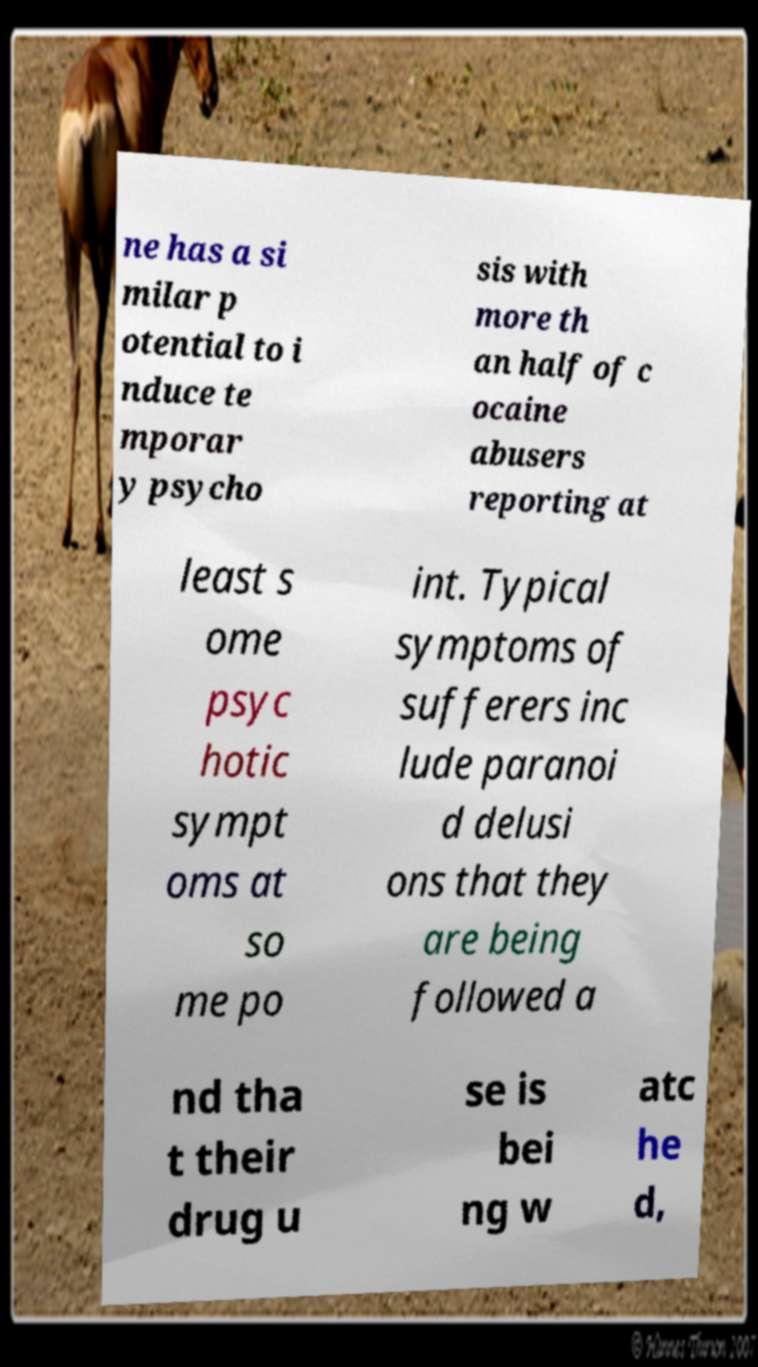Can you read and provide the text displayed in the image?This photo seems to have some interesting text. Can you extract and type it out for me? ne has a si milar p otential to i nduce te mporar y psycho sis with more th an half of c ocaine abusers reporting at least s ome psyc hotic sympt oms at so me po int. Typical symptoms of sufferers inc lude paranoi d delusi ons that they are being followed a nd tha t their drug u se is bei ng w atc he d, 